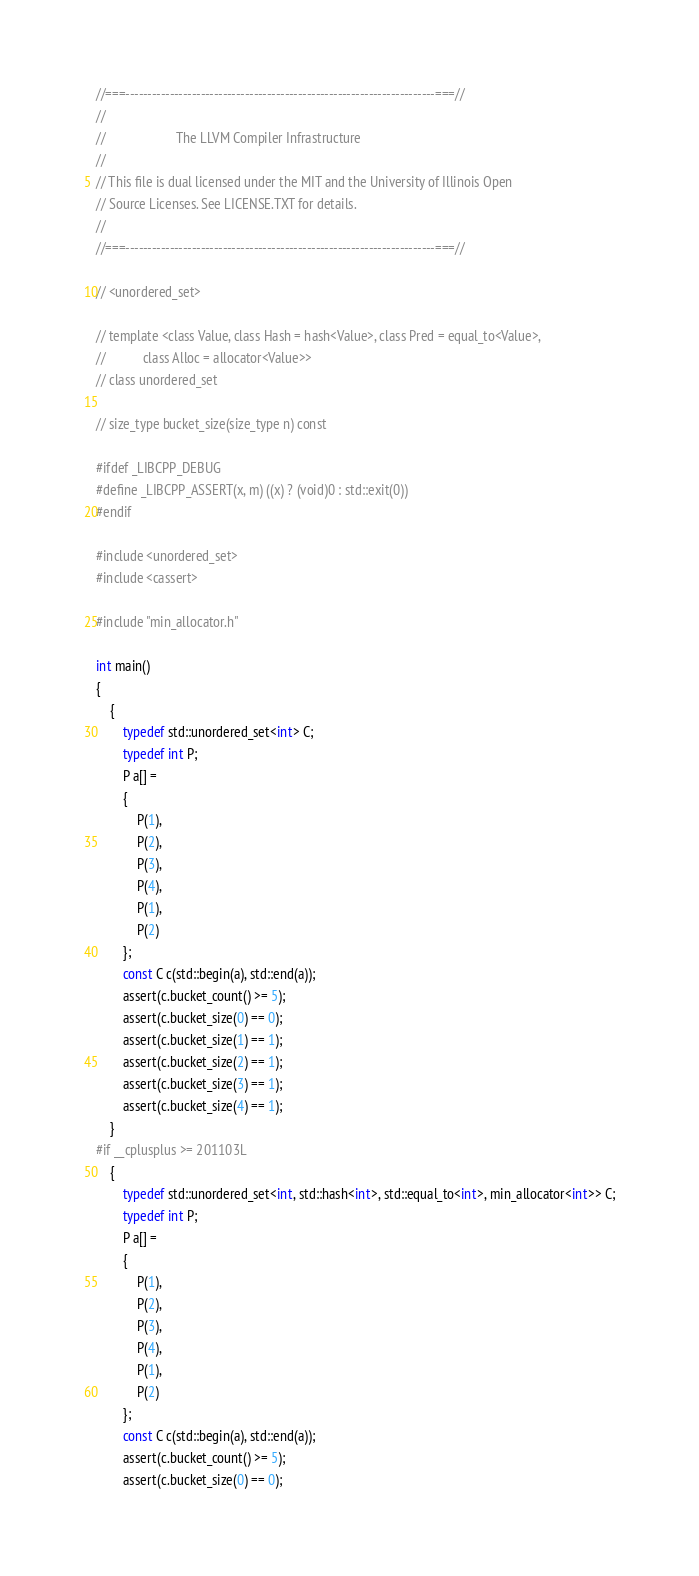<code> <loc_0><loc_0><loc_500><loc_500><_C++_>//===----------------------------------------------------------------------===//
//
//                     The LLVM Compiler Infrastructure
//
// This file is dual licensed under the MIT and the University of Illinois Open
// Source Licenses. See LICENSE.TXT for details.
//
//===----------------------------------------------------------------------===//

// <unordered_set>

// template <class Value, class Hash = hash<Value>, class Pred = equal_to<Value>,
//           class Alloc = allocator<Value>>
// class unordered_set

// size_type bucket_size(size_type n) const

#ifdef _LIBCPP_DEBUG
#define _LIBCPP_ASSERT(x, m) ((x) ? (void)0 : std::exit(0))
#endif

#include <unordered_set>
#include <cassert>

#include "min_allocator.h"

int main()
{
    {
        typedef std::unordered_set<int> C;
        typedef int P;
        P a[] =
        {
            P(1),
            P(2),
            P(3),
            P(4),
            P(1),
            P(2)
        };
        const C c(std::begin(a), std::end(a));
        assert(c.bucket_count() >= 5);
        assert(c.bucket_size(0) == 0);
        assert(c.bucket_size(1) == 1);
        assert(c.bucket_size(2) == 1);
        assert(c.bucket_size(3) == 1);
        assert(c.bucket_size(4) == 1);
    }
#if __cplusplus >= 201103L
    {
        typedef std::unordered_set<int, std::hash<int>, std::equal_to<int>, min_allocator<int>> C;
        typedef int P;
        P a[] =
        {
            P(1),
            P(2),
            P(3),
            P(4),
            P(1),
            P(2)
        };
        const C c(std::begin(a), std::end(a));
        assert(c.bucket_count() >= 5);
        assert(c.bucket_size(0) == 0);</code> 